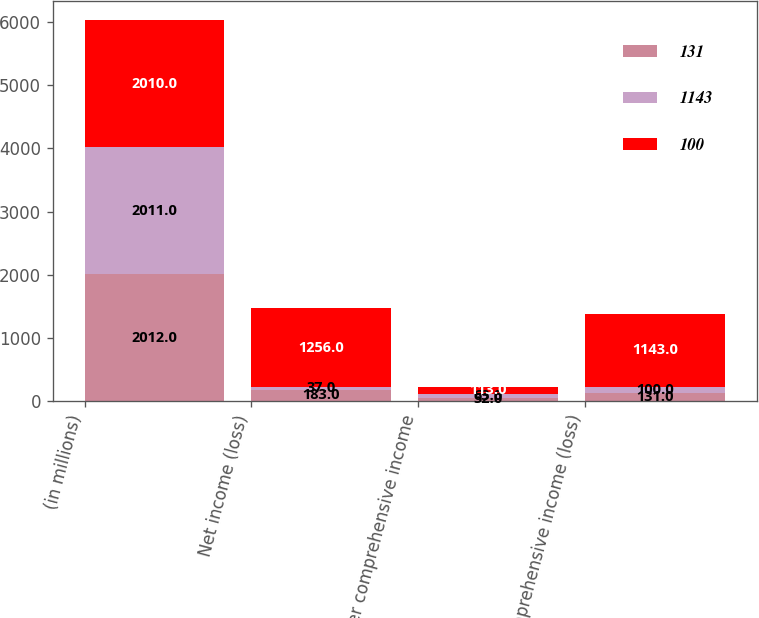Convert chart to OTSL. <chart><loc_0><loc_0><loc_500><loc_500><stacked_bar_chart><ecel><fcel>(in millions)<fcel>Net income (loss)<fcel>Other comprehensive income<fcel>Comprehensive income (loss)<nl><fcel>131<fcel>2012<fcel>183<fcel>52<fcel>131<nl><fcel>1143<fcel>2011<fcel>37<fcel>63<fcel>100<nl><fcel>100<fcel>2010<fcel>1256<fcel>113<fcel>1143<nl></chart> 